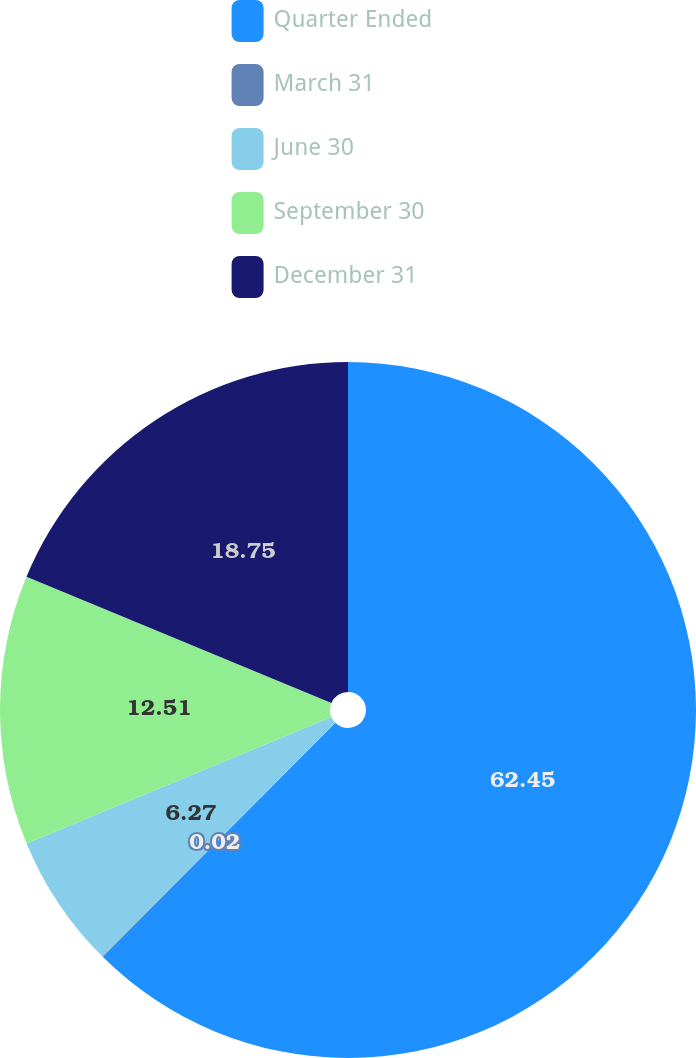Convert chart to OTSL. <chart><loc_0><loc_0><loc_500><loc_500><pie_chart><fcel>Quarter Ended<fcel>March 31<fcel>June 30<fcel>September 30<fcel>December 31<nl><fcel>62.45%<fcel>0.02%<fcel>6.27%<fcel>12.51%<fcel>18.75%<nl></chart> 